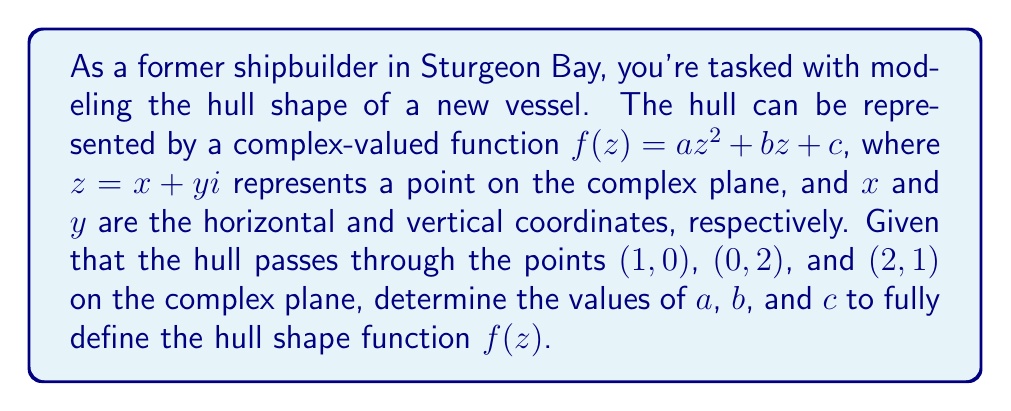Help me with this question. To solve this problem, we'll follow these steps:

1) First, let's express the given points as complex numbers:
   $(1,0) \rightarrow 1+0i = 1$
   $(0,2) \rightarrow 0+2i = 2i$
   $(2,1) \rightarrow 2+i$

2) Now, we can set up three equations using $f(z) = az^2 + bz + c$:

   For $z=1$: $f(1) = a(1)^2 + b(1) + c = a + b + c = 0$
   For $z=2i$: $f(2i) = a(2i)^2 + b(2i) + c = -4a + 2bi + c = 2$
   For $z=2+i$: $f(2+i) = a(2+i)^2 + b(2+i) + c = a(4+4i-1) + 2b + bi + c = 3a + 4ai + 2b + bi + c = 1 + i$

3) From these, we get three complex equations:

   $a + b + c = 0$ ... (1)
   $-4a + 2bi + c = 2$ ... (2)
   $3a + 2b + c + (4a + b)i = 1 + i$ ... (3)

4) Equating real and imaginary parts in (3):
   $3a + 2b + c = 1$ ... (4)
   $4a + b = 1$ ... (5)

5) From (1) and (4):
   $3a + 2b + c = 1$
   $a + b + c = 0$
   Subtracting these equations: $2a + b = 1$ ... (6)

6) From (5) and (6):
   $4a + b = 1$
   $2a + b = 1$
   Subtracting these equations: $2a = 0$, so $a = 0$

7) Substituting $a = 0$ in (5): $b = 1$

8) Substituting $a = 0$ and $b = 1$ in (1): $c = -1$

Therefore, we have determined that $a = 0$, $b = 1$, and $c = -1$.
Answer: The complex-valued function representing the hull shape is:
$$f(z) = z - 1$$ 